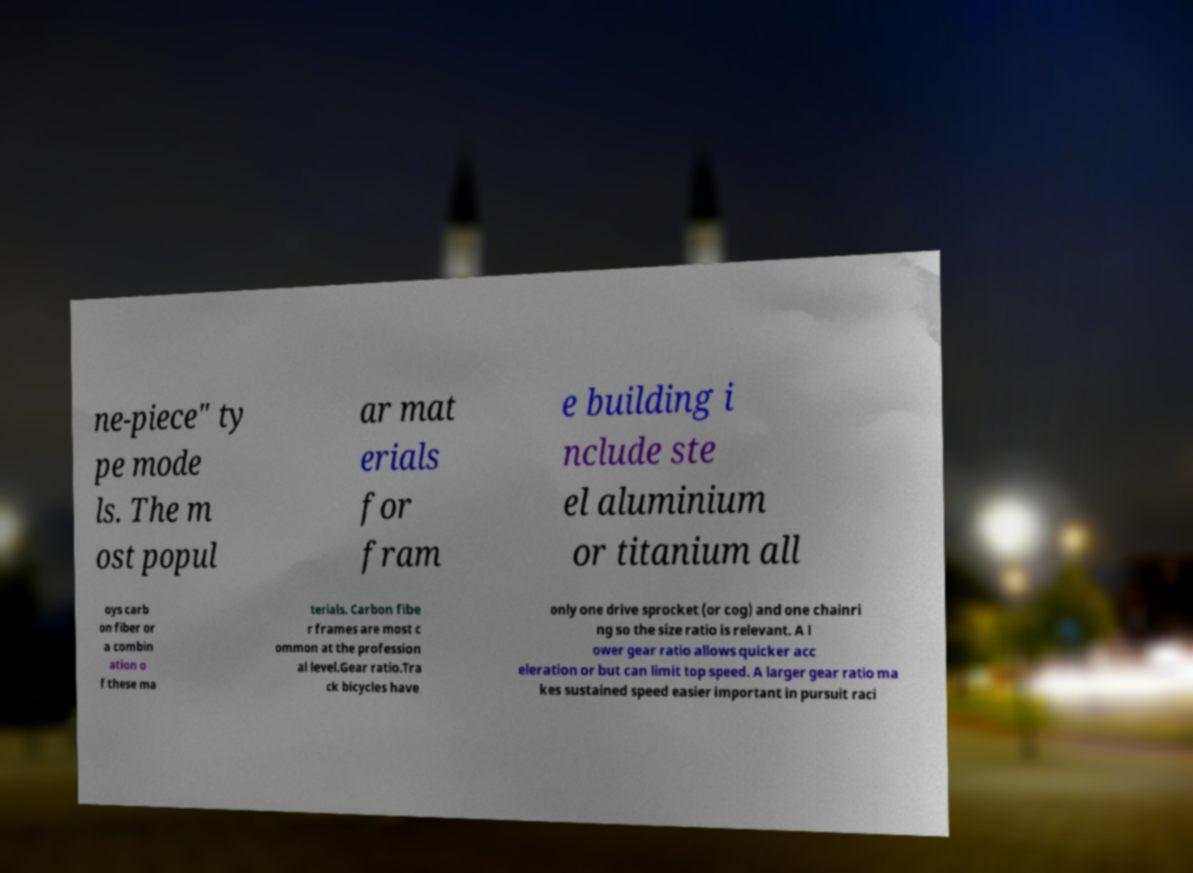For documentation purposes, I need the text within this image transcribed. Could you provide that? ne-piece" ty pe mode ls. The m ost popul ar mat erials for fram e building i nclude ste el aluminium or titanium all oys carb on fiber or a combin ation o f these ma terials. Carbon fibe r frames are most c ommon at the profession al level.Gear ratio.Tra ck bicycles have only one drive sprocket (or cog) and one chainri ng so the size ratio is relevant. A l ower gear ratio allows quicker acc eleration or but can limit top speed. A larger gear ratio ma kes sustained speed easier important in pursuit raci 